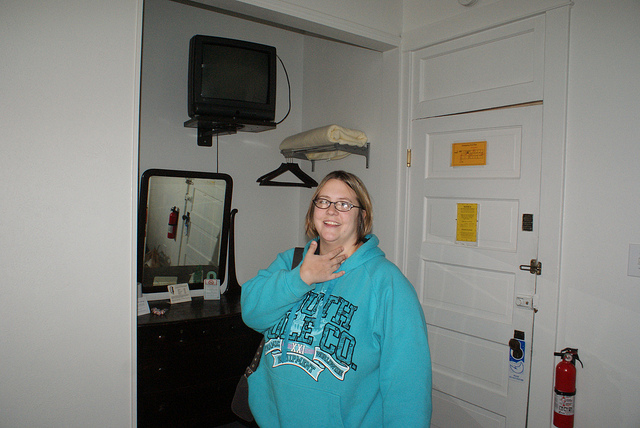Identify the text contained in this image. CO 